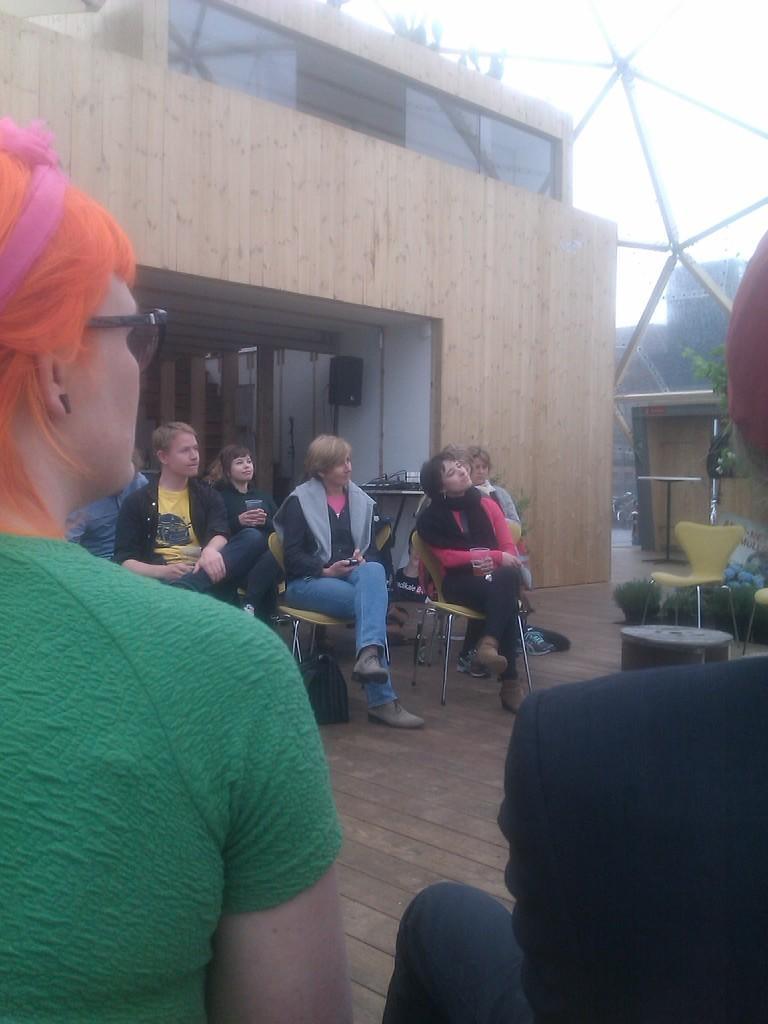How would you summarize this image in a sentence or two? In this image I can see few persons are sitting on chairs, the brown colored floor, a building, a black colored object, a chair and a tree. In the background I can see the sky. 